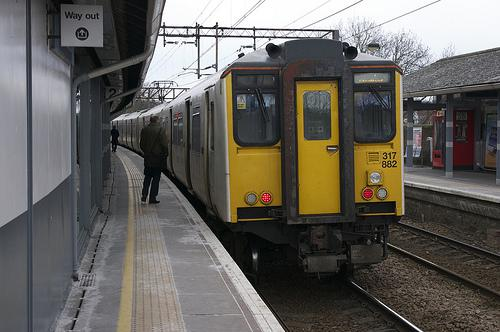Question: how many people are pictured?
Choices:
A. 3.
B. 1.
C. 0.
D. 2.
Answer with the letter. Answer: D Question: who is standing on the platform?
Choices:
A. Troupe of clowns.
B. Man.
C. Nobody.
D. Stationmaster.
Answer with the letter. Answer: B Question: what is the man wearing?
Choices:
A. Jacket.
B. Medical scrubs.
C. A bikini.
D. A spacesuit.
Answer with the letter. Answer: A Question: what does the man have on his shoulder?
Choices:
A. Bag.
B. Small child.
C. Fur cape.
D. Bird poop.
Answer with the letter. Answer: A Question: where is the train located?
Choices:
A. In the ditch beside the tracks.
B. Tracks.
C. In the assembly line.
D. At station platform.
Answer with the letter. Answer: B 